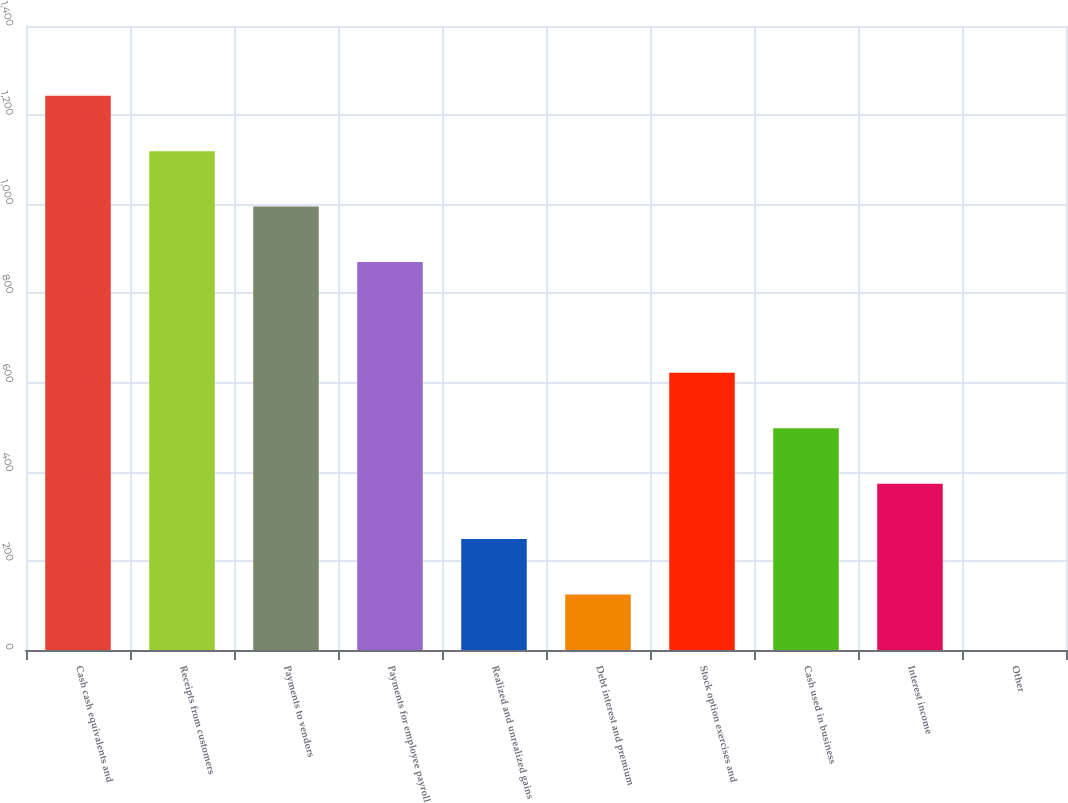<chart> <loc_0><loc_0><loc_500><loc_500><bar_chart><fcel>Cash cash equivalents and<fcel>Receipts from customers<fcel>Payments to vendors<fcel>Payments for employee payroll<fcel>Realized and unrealized gains<fcel>Debt interest and premium<fcel>Stock option exercises and<fcel>Cash used in business<fcel>Interest income<fcel>Other<nl><fcel>1243.4<fcel>1119.08<fcel>994.76<fcel>870.44<fcel>248.84<fcel>124.52<fcel>621.8<fcel>497.48<fcel>373.16<fcel>0.2<nl></chart> 